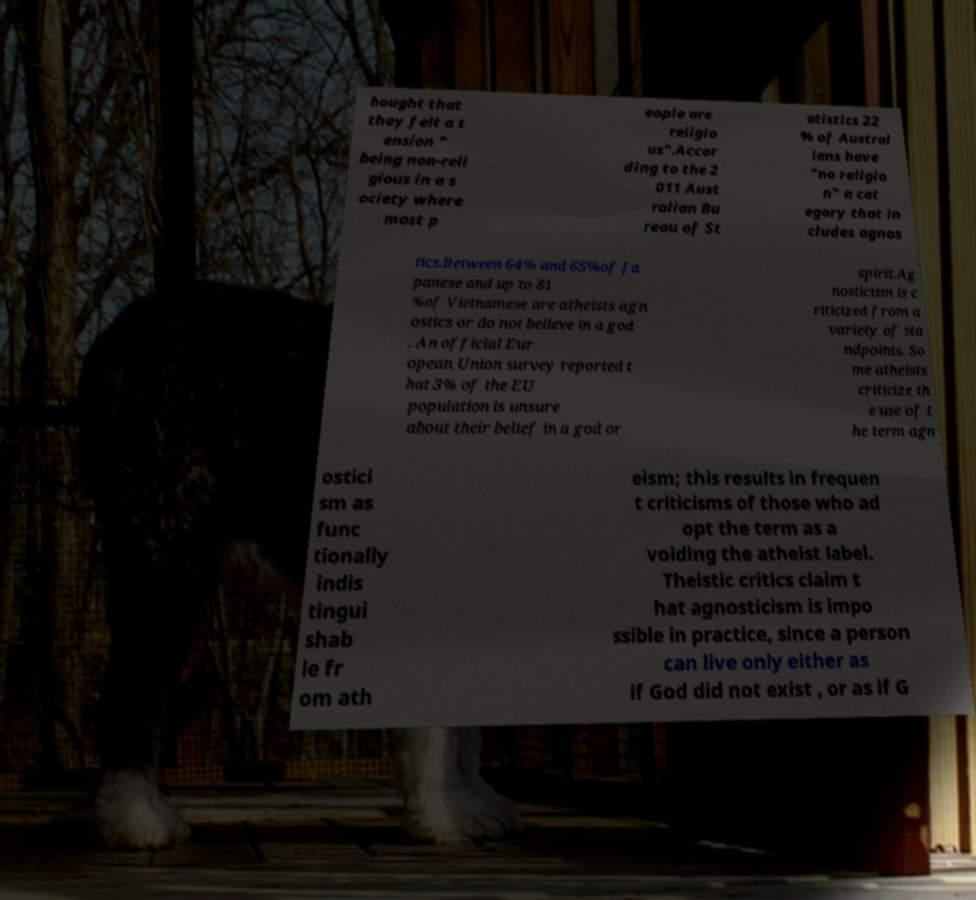Please identify and transcribe the text found in this image. hought that they felt a t ension " being non-reli gious in a s ociety where most p eople are religio us".Accor ding to the 2 011 Aust ralian Bu reau of St atistics 22 % of Austral ians have "no religio n" a cat egory that in cludes agnos tics.Between 64% and 65%of Ja panese and up to 81 %of Vietnamese are atheists agn ostics or do not believe in a god . An official Eur opean Union survey reported t hat 3% of the EU population is unsure about their belief in a god or spirit.Ag nosticism is c riticized from a variety of sta ndpoints. So me atheists criticize th e use of t he term agn ostici sm as func tionally indis tingui shab le fr om ath eism; this results in frequen t criticisms of those who ad opt the term as a voiding the atheist label. Theistic critics claim t hat agnosticism is impo ssible in practice, since a person can live only either as if God did not exist , or as if G 